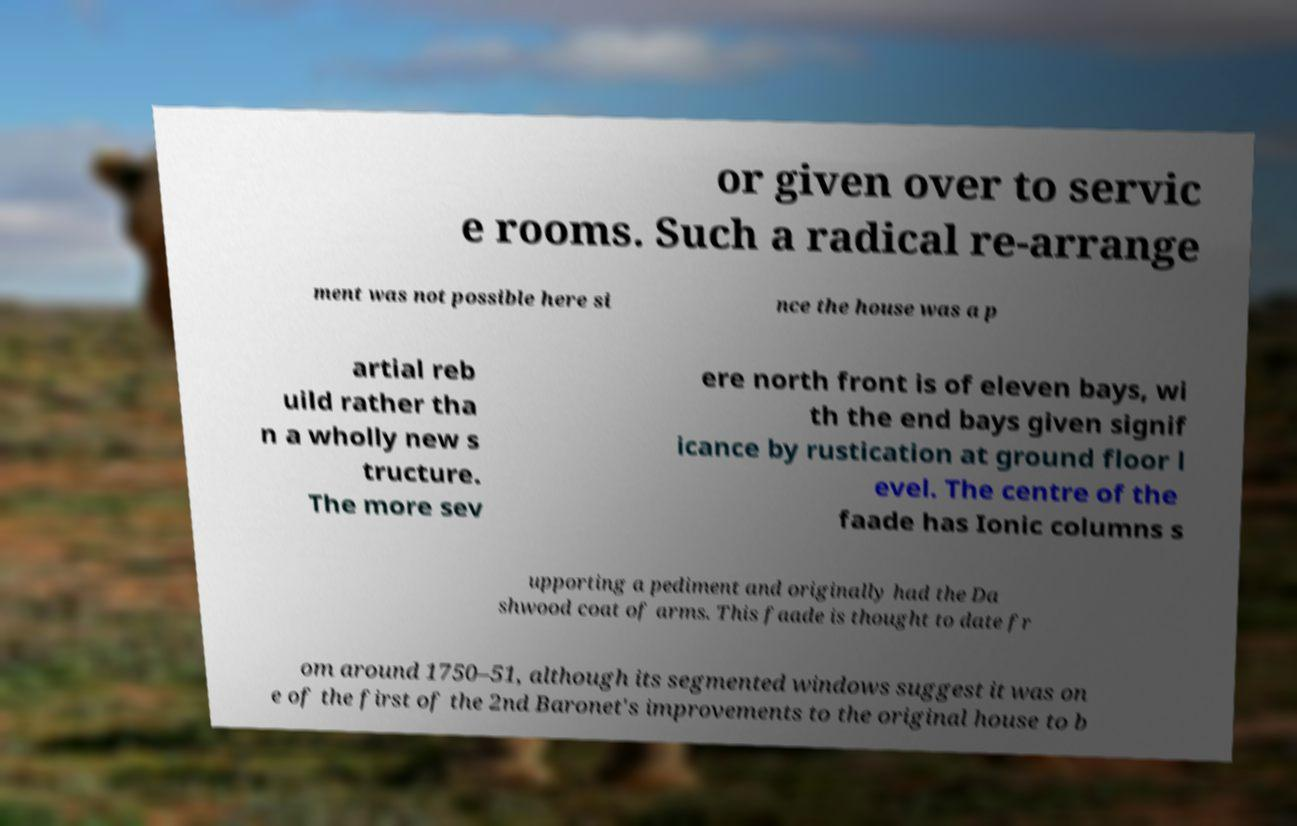Could you extract and type out the text from this image? or given over to servic e rooms. Such a radical re-arrange ment was not possible here si nce the house was a p artial reb uild rather tha n a wholly new s tructure. The more sev ere north front is of eleven bays, wi th the end bays given signif icance by rustication at ground floor l evel. The centre of the faade has Ionic columns s upporting a pediment and originally had the Da shwood coat of arms. This faade is thought to date fr om around 1750–51, although its segmented windows suggest it was on e of the first of the 2nd Baronet's improvements to the original house to b 